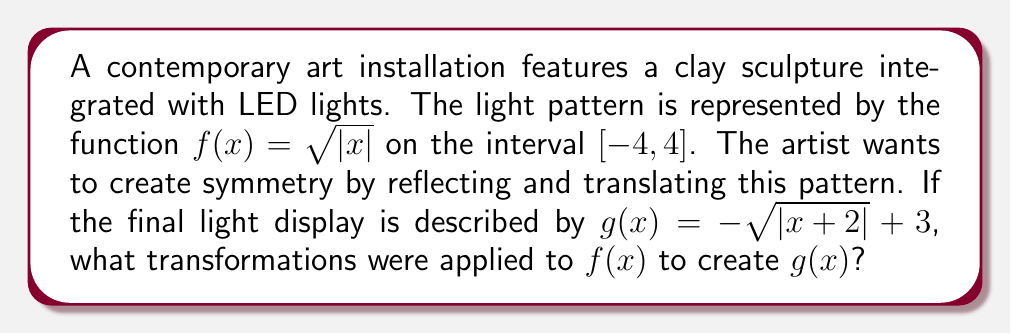Give your solution to this math problem. Let's analyze the transformations step-by-step:

1) Start with $f(x) = \sqrt{|x|}$

2) Inside the absolute value brackets, we see $(x+2)$. This represents a horizontal shift:
   $\sqrt{|x+2|}$
   This shifts the graph 2 units to the left.

3) The negative sign outside the square root reflects the function over the x-axis:
   $-\sqrt{|x+2|}$

4) Finally, we add 3, which represents a vertical shift up by 3 units:
   $-\sqrt{|x+2|} + 3$

Therefore, to transform $f(x)$ into $g(x)$, we apply the following transformations in order:
a) Shift 2 units left
b) Reflect over the x-axis
c) Shift 3 units up

This creates symmetry by reflecting the original pattern and repositioning it in the coordinate plane.
Answer: Left shift by 2, reflection over x-axis, up shift by 3 